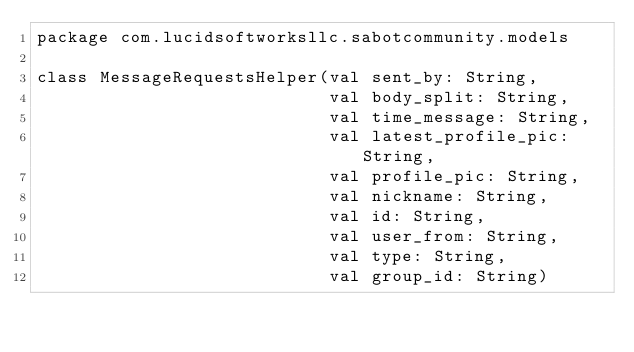<code> <loc_0><loc_0><loc_500><loc_500><_Kotlin_>package com.lucidsoftworksllc.sabotcommunity.models

class MessageRequestsHelper(val sent_by: String,
                            val body_split: String,
                            val time_message: String,
                            val latest_profile_pic: String,
                            val profile_pic: String,
                            val nickname: String,
                            val id: String,
                            val user_from: String,
                            val type: String,
                            val group_id: String)</code> 